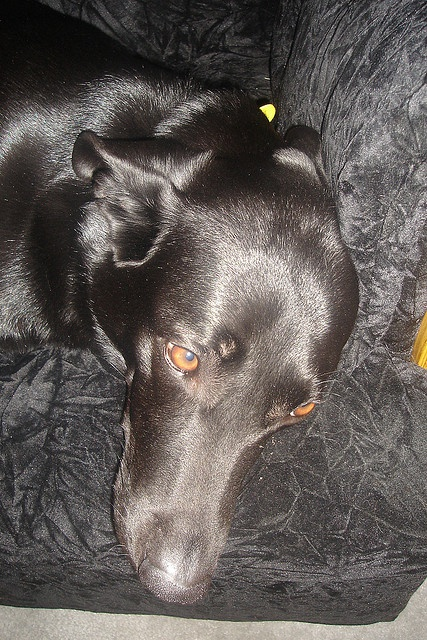Describe the objects in this image and their specific colors. I can see couch in black, gray, and darkgray tones and dog in black, gray, darkgray, and lightgray tones in this image. 